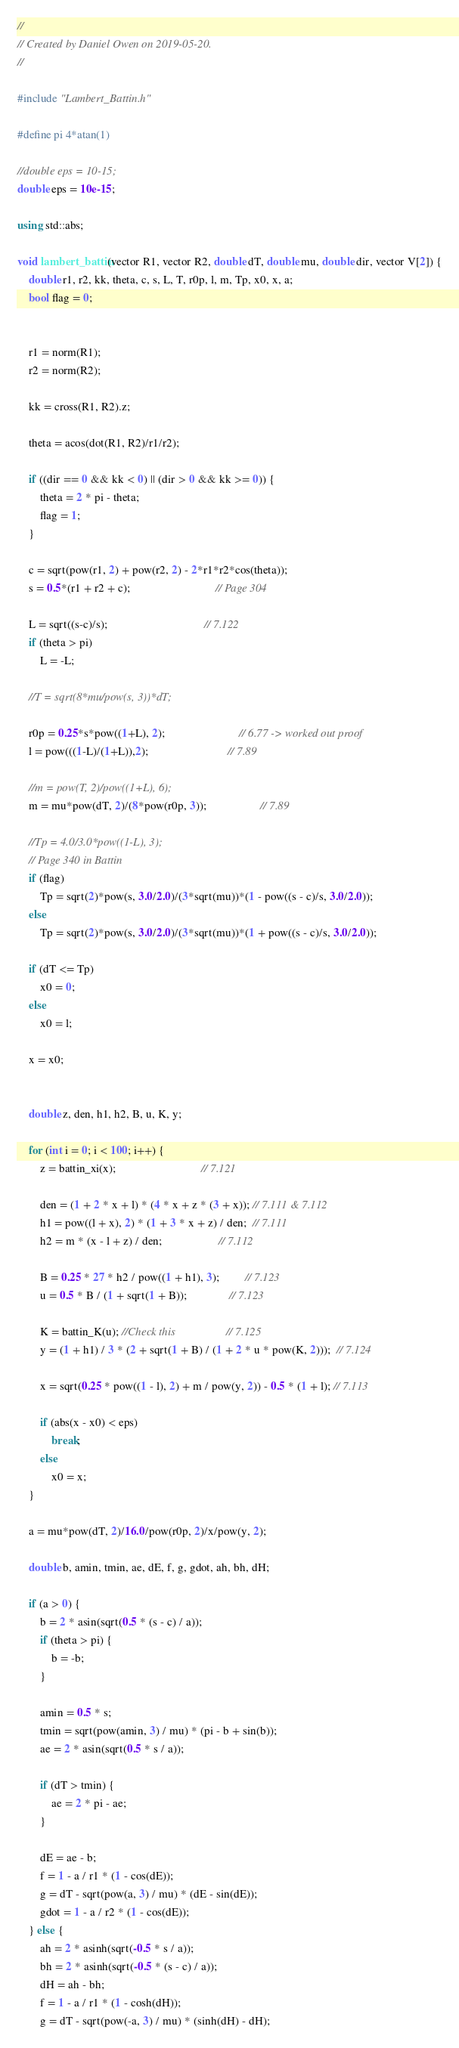<code> <loc_0><loc_0><loc_500><loc_500><_C++_>//
// Created by Daniel Owen on 2019-05-20.
//

#include "Lambert_Battin.h"

#define pi 4*atan(1)

//double eps = 10-15;
double eps = 10e-15;

using std::abs;

void lambert_battin(vector R1, vector R2, double dT, double mu, double dir, vector V[2]) {
    double r1, r2, kk, theta, c, s, L, T, r0p, l, m, Tp, x0, x, a;
    bool flag = 0;


    r1 = norm(R1);
    r2 = norm(R2);

    kk = cross(R1, R2).z;

    theta = acos(dot(R1, R2)/r1/r2);

    if ((dir == 0 && kk < 0) || (dir > 0 && kk >= 0)) {
        theta = 2 * pi - theta;
        flag = 1;
    }

    c = sqrt(pow(r1, 2) + pow(r2, 2) - 2*r1*r2*cos(theta));
    s = 0.5*(r1 + r2 + c);                              // Page 304

    L = sqrt((s-c)/s);                                  // 7.122
    if (theta > pi)
        L = -L;

    //T = sqrt(8*mu/pow(s, 3))*dT;

    r0p = 0.25*s*pow((1+L), 2);                          // 6.77 -> worked out proof
    l = pow(((1-L)/(1+L)),2);                            // 7.89

    //m = pow(T, 2)/pow((1+L), 6);
    m = mu*pow(dT, 2)/(8*pow(r0p, 3));                   // 7.89

    //Tp = 4.0/3.0*pow((1-L), 3);
    // Page 340 in Battin
    if (flag)
        Tp = sqrt(2)*pow(s, 3.0/2.0)/(3*sqrt(mu))*(1 - pow((s - c)/s, 3.0/2.0));
    else
        Tp = sqrt(2)*pow(s, 3.0/2.0)/(3*sqrt(mu))*(1 + pow((s - c)/s, 3.0/2.0));

    if (dT <= Tp)
        x0 = 0;
    else
        x0 = l;

    x = x0;


    double z, den, h1, h2, B, u, K, y;

    for (int i = 0; i < 100; i++) {
        z = battin_xi(x);                              // 7.121

        den = (1 + 2 * x + l) * (4 * x + z * (3 + x)); // 7.111 & 7.112
        h1 = pow((l + x), 2) * (1 + 3 * x + z) / den;  // 7.111
        h2 = m * (x - l + z) / den;                    // 7.112

        B = 0.25 * 27 * h2 / pow((1 + h1), 3);         // 7.123
        u = 0.5 * B / (1 + sqrt(1 + B));               // 7.123

        K = battin_K(u); //Check this                  // 7.125
        y = (1 + h1) / 3 * (2 + sqrt(1 + B) / (1 + 2 * u * pow(K, 2)));  // 7.124

        x = sqrt(0.25 * pow((1 - l), 2) + m / pow(y, 2)) - 0.5 * (1 + l); // 7.113

        if (abs(x - x0) < eps)
            break;
        else
            x0 = x;
    }

    a = mu*pow(dT, 2)/16.0/pow(r0p, 2)/x/pow(y, 2);

    double b, amin, tmin, ae, dE, f, g, gdot, ah, bh, dH;

    if (a > 0) {
        b = 2 * asin(sqrt(0.5 * (s - c) / a));
        if (theta > pi) {
            b = -b;
        }

        amin = 0.5 * s;
        tmin = sqrt(pow(amin, 3) / mu) * (pi - b + sin(b));
        ae = 2 * asin(sqrt(0.5 * s / a));

        if (dT > tmin) {
            ae = 2 * pi - ae;
        }

        dE = ae - b;
        f = 1 - a / r1 * (1 - cos(dE));
        g = dT - sqrt(pow(a, 3) / mu) * (dE - sin(dE));
        gdot = 1 - a / r2 * (1 - cos(dE));
    } else {
        ah = 2 * asinh(sqrt(-0.5 * s / a));
        bh = 2 * asinh(sqrt(-0.5 * (s - c) / a));
        dH = ah - bh;
        f = 1 - a / r1 * (1 - cosh(dH));
        g = dT - sqrt(pow(-a, 3) / mu) * (sinh(dH) - dH);</code> 